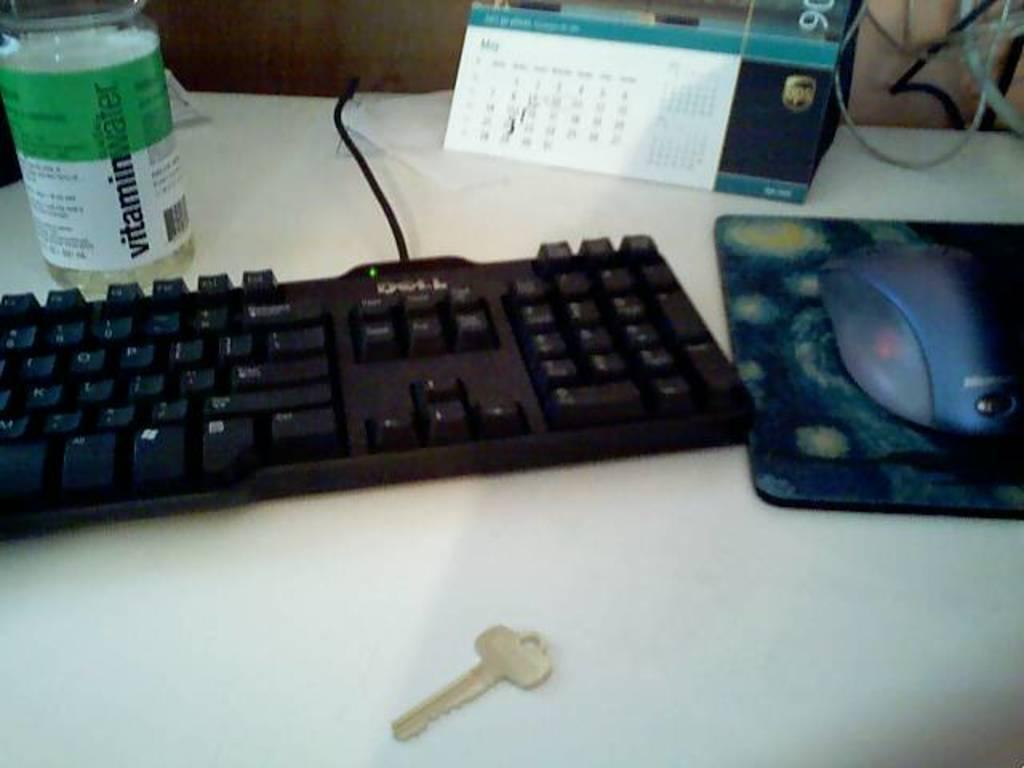<image>
Present a compact description of the photo's key features. A computer desk with a keyboard and mouse has a bottle next to it that says Vitamin Water. 